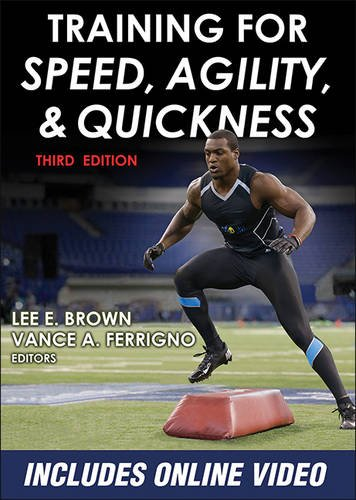Who are the editors of this book? The editors of the book are Lee E. Brown and Vance A. Ferrigno, both of whom are reputed in the field of sports training and physical fitness. What additional resources come with the book? The book includes access to online videos that provide visual demonstrations of the training exercises and techniques discussed in the text. 